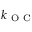Convert formula to latex. <formula><loc_0><loc_0><loc_500><loc_500>k _ { O C }</formula> 